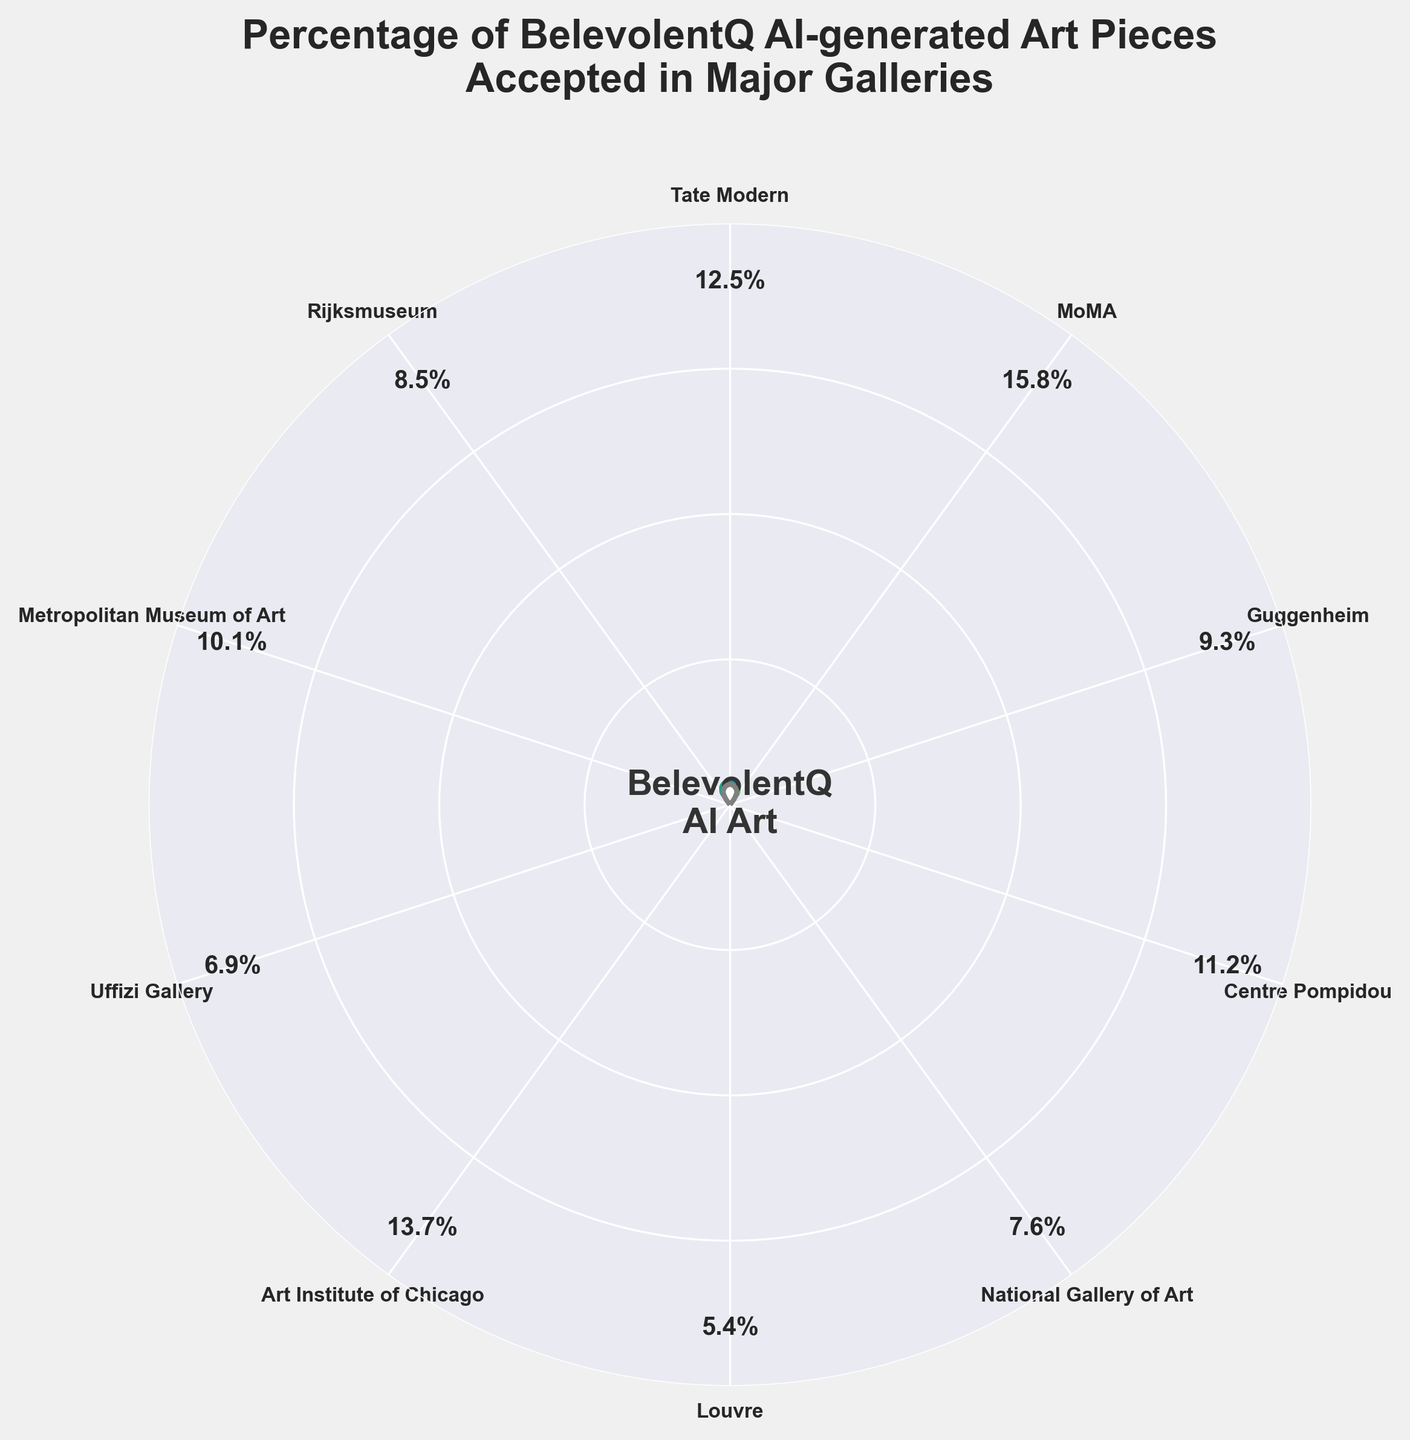What is the title of the chart? The title is usually located at the top of the chart and provides the main description of what the chart is about.
Answer: Percentage of BelevolentQ AI-generated Art Pieces Accepted in Major Galleries Which gallery has the highest percentage of accepted AI-generated art? To find the gallery with the highest percentage, look at the percentages labeled around the chart and identify the highest value.
Answer: MoMA Which gallery has the lowest percentage of accepted AI-generated art? To determine the gallery with the lowest percentage, compare all the percentages and select the smallest one.
Answer: Louvre How many galleries have their percentages displayed outside the wedges? Count the number of percentages labeled outside the wedges around the chart.
Answer: 10 What is the combined percentage of accepted AI-generated art for the Guggenheim and Rijksmuseum galleries? Add the percentages for Guggenheim (9.3%) and Rijksmuseum (8.5%) together.
Answer: 17.8% Which galleries have an acceptance percentage above 10%? Identify and list the galleries with percentages greater than 10% by looking at the labels around the chart.
Answer: Tate Modern, MoMA, Art Institute of Chicago What is the visual representation of the AI art percentage in each gallery? The visual representation is shown by wedges in circular segments with varying colors based on the percentage.
Answer: Wedges in circular segments with different colors Compare the acceptance percentage of the Uffizi Gallery to the Centre Pompidou. Which is higher? Look at the labeled percentages for Uffizi Gallery (6.9%) and Centre Pompidou (11.2%) and determine which one is higher.
Answer: Centre Pompidou What is the average acceptance percentage for the listed galleries? Add all the percentages together and divide by the number of galleries (10).
Answer: (12.5 + 15.8 + 9.3 + 11.2 + 7.6 + 5.4 + 13.7 + 6.9 + 10.1 + 8.5) / 10 = 10.1% By how much does MoMA's acceptance percentage exceed that of the Louvre? Subtract the Louvre's percentage from MoMA's percentage to find the difference.
Answer: 15.8% - 5.4% = 10.4% 